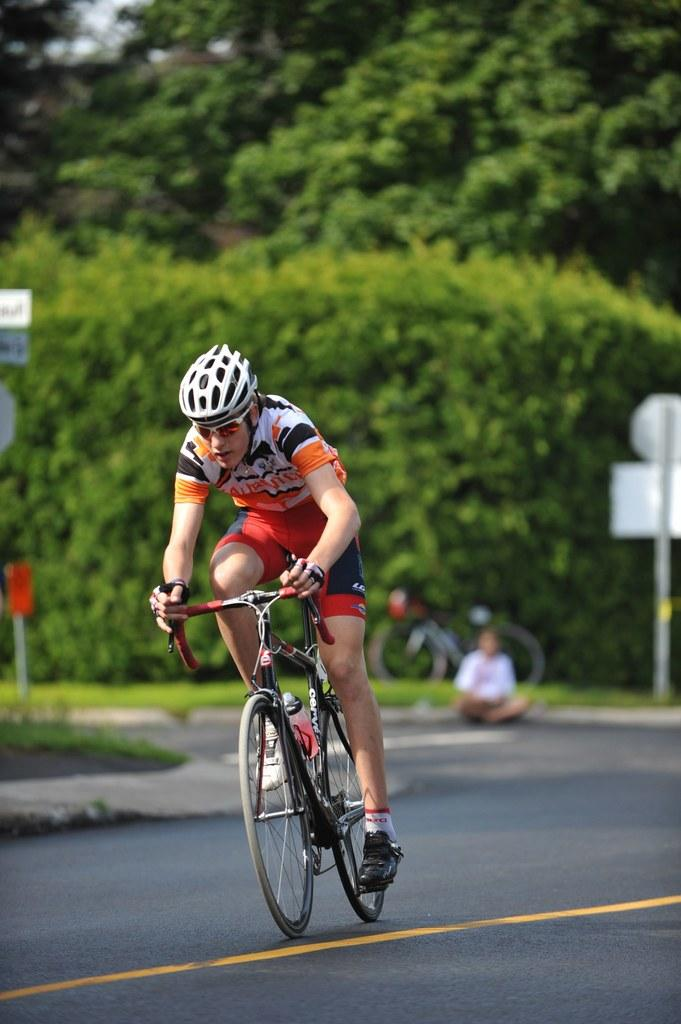What is the man in the image doing? The man is riding a bicycle in the image. Where is the man riding the bicycle? The man is on a road. What can be seen in the background of the image? There is a sign board, a pole, a person, another bicycle, and trees in the background of the image. What type of pancake is the man eating while riding the bicycle in the image? There is no pancake present in the image, and the man is not eating anything while riding the bicycle. 